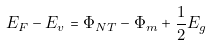<formula> <loc_0><loc_0><loc_500><loc_500>E _ { F } - E _ { v } = \Phi _ { N T } - \Phi _ { m } + \frac { 1 } { 2 } E _ { g }</formula> 